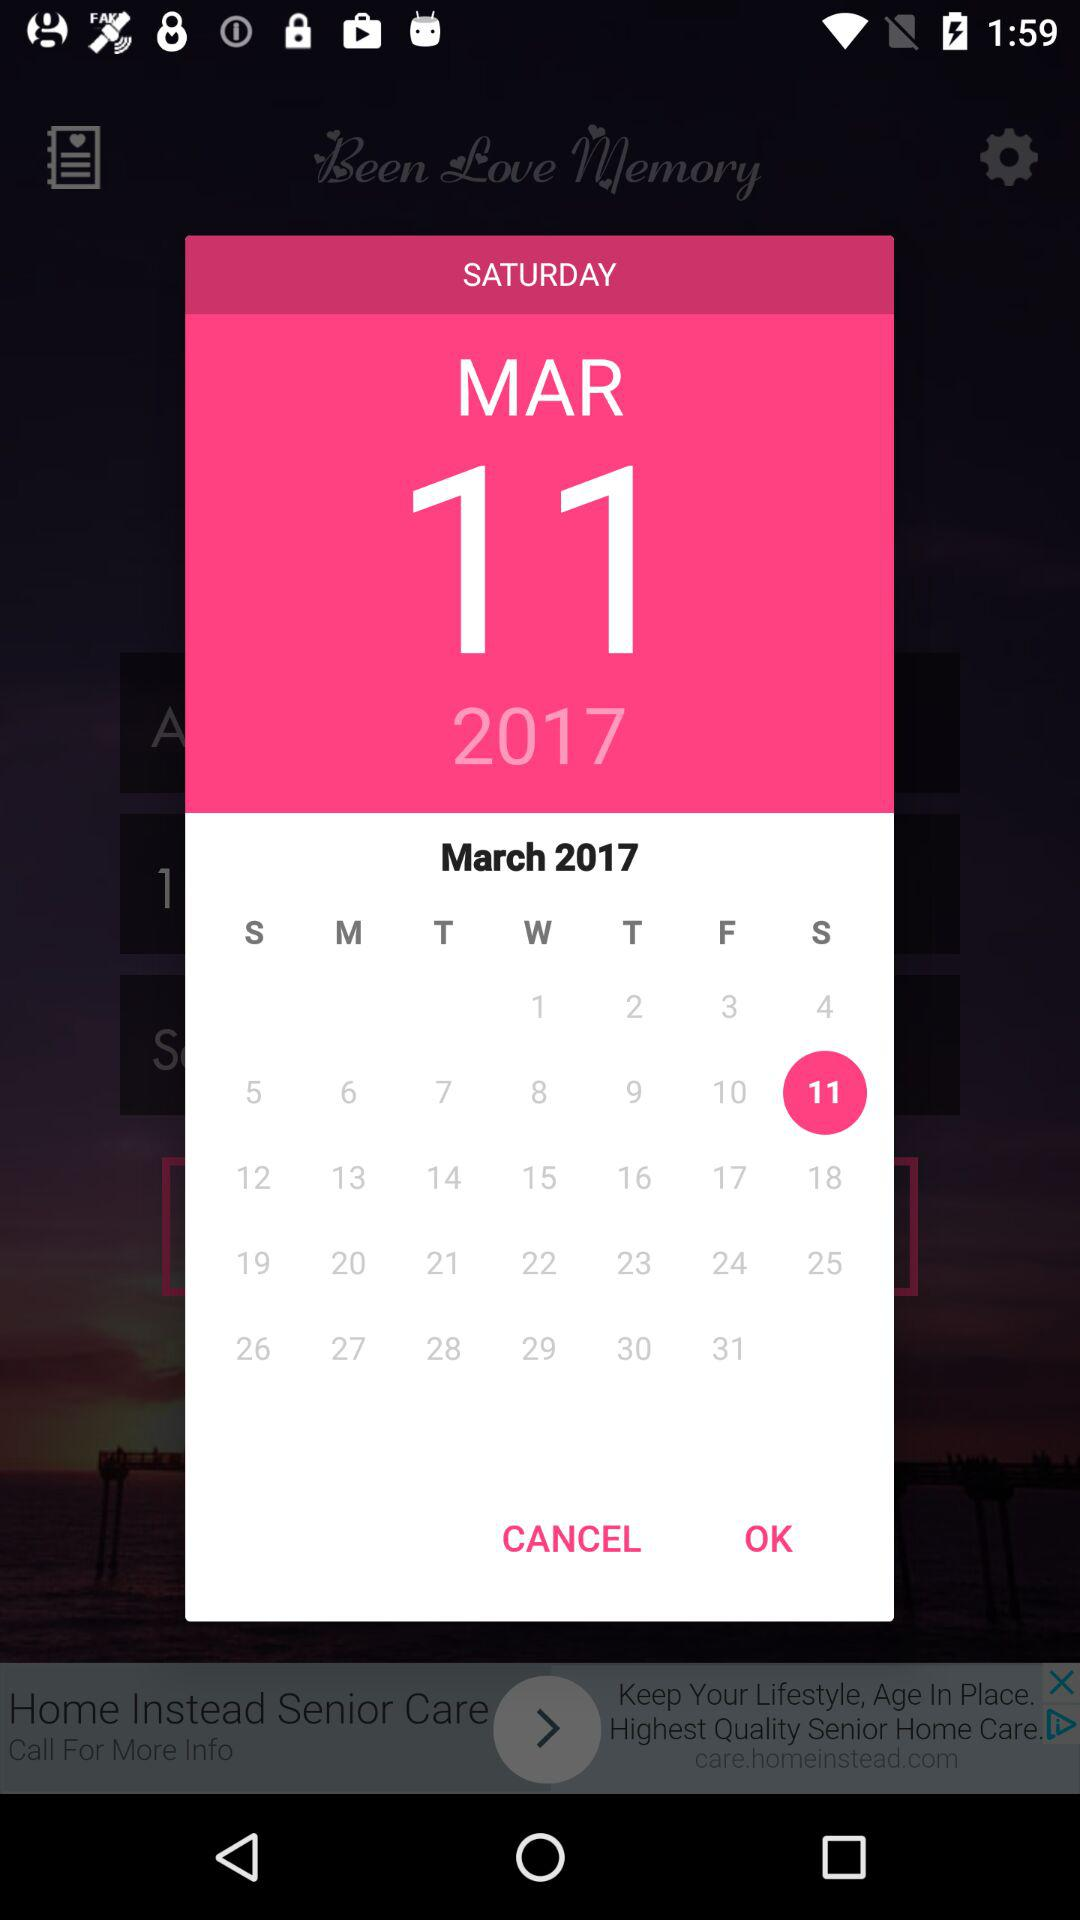What is the day of March 11, 2017? The day is Saturday. 